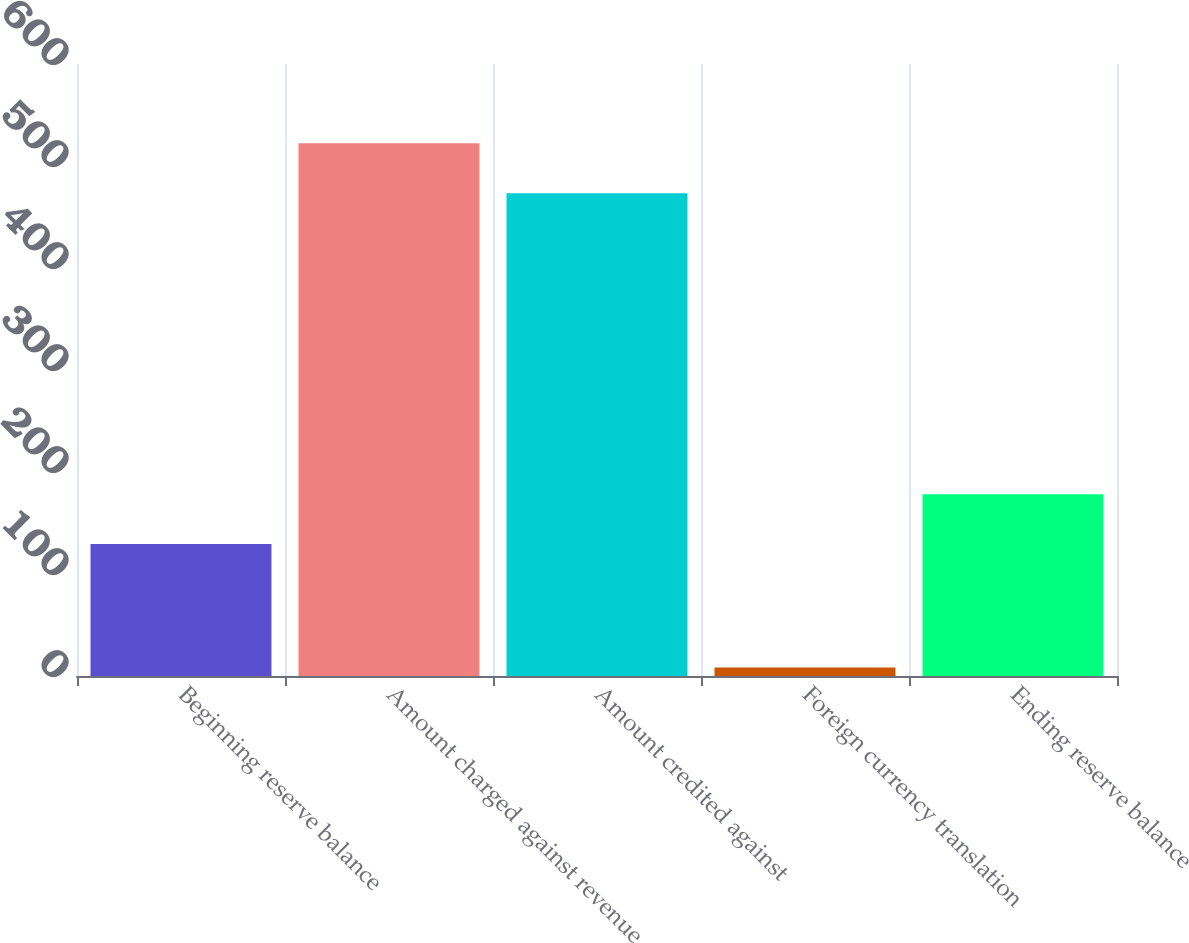Convert chart. <chart><loc_0><loc_0><loc_500><loc_500><bar_chart><fcel>Beginning reserve balance<fcel>Amount charged against revenue<fcel>Amount credited against<fcel>Foreign currency translation<fcel>Ending reserve balance<nl><fcel>129.4<fcel>522.23<fcel>473.4<fcel>8.4<fcel>178.23<nl></chart> 